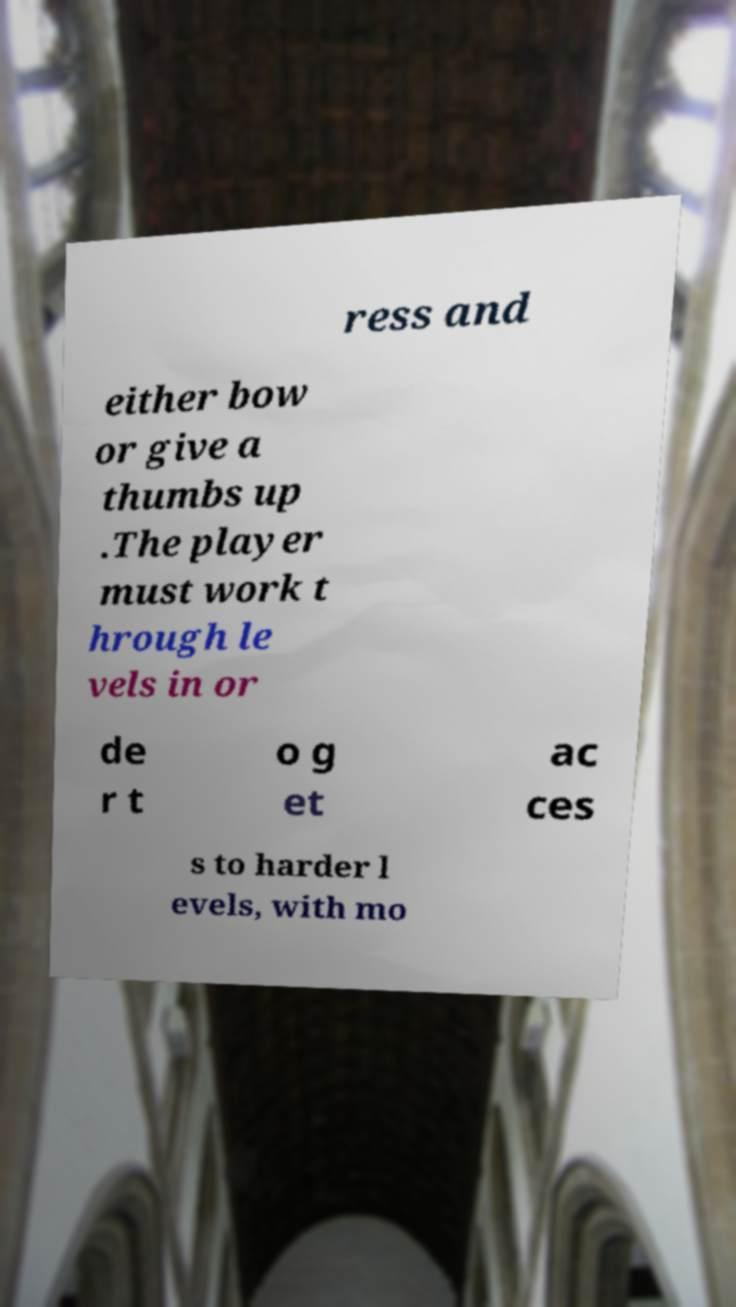Could you assist in decoding the text presented in this image and type it out clearly? ress and either bow or give a thumbs up .The player must work t hrough le vels in or de r t o g et ac ces s to harder l evels, with mo 